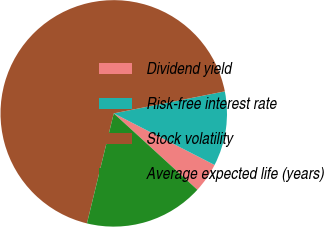<chart> <loc_0><loc_0><loc_500><loc_500><pie_chart><fcel>Dividend yield<fcel>Risk-free interest rate<fcel>Stock volatility<fcel>Average expected life (years)<nl><fcel>4.26%<fcel>10.64%<fcel>68.09%<fcel>17.02%<nl></chart> 